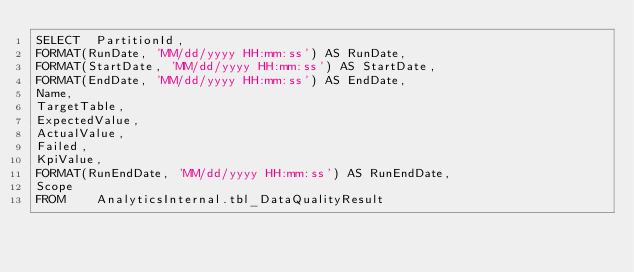<code> <loc_0><loc_0><loc_500><loc_500><_SQL_>SELECT  PartitionId,
FORMAT(RunDate, 'MM/dd/yyyy HH:mm:ss') AS RunDate,
FORMAT(StartDate, 'MM/dd/yyyy HH:mm:ss') AS StartDate,
FORMAT(EndDate, 'MM/dd/yyyy HH:mm:ss') AS EndDate,
Name,
TargetTable,
ExpectedValue,
ActualValue,
Failed,
KpiValue,
FORMAT(RunEndDate, 'MM/dd/yyyy HH:mm:ss') AS RunEndDate,
Scope
FROM    AnalyticsInternal.tbl_DataQualityResult</code> 